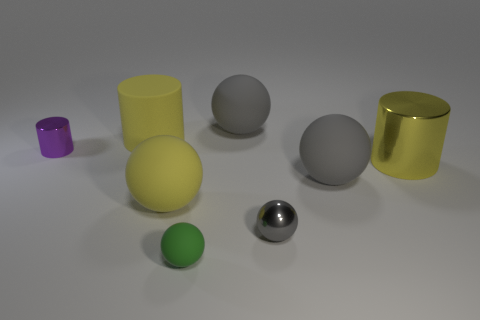How many green objects are either tiny matte things or metal objects?
Provide a short and direct response. 1. Is there any other thing that is the same material as the tiny cylinder?
Provide a short and direct response. Yes. Is the gray object to the left of the tiny gray ball made of the same material as the large yellow sphere?
Ensure brevity in your answer.  Yes. What number of objects are large purple balls or big cylinders that are on the right side of the yellow sphere?
Offer a terse response. 1. There is a large gray ball that is behind the metallic cylinder that is on the left side of the big metal cylinder; what number of large yellow cylinders are behind it?
Make the answer very short. 0. There is a tiny object that is behind the large yellow metallic cylinder; does it have the same shape as the gray metallic object?
Your answer should be compact. No. There is a tiny object that is behind the yellow sphere; are there any big yellow matte balls to the left of it?
Give a very brief answer. No. How many blue metallic things are there?
Offer a very short reply. 0. There is a rubber object that is on the left side of the green matte object and in front of the yellow shiny object; what is its color?
Offer a very short reply. Yellow. What is the size of the purple metallic object that is the same shape as the big yellow metal object?
Your answer should be very brief. Small. 